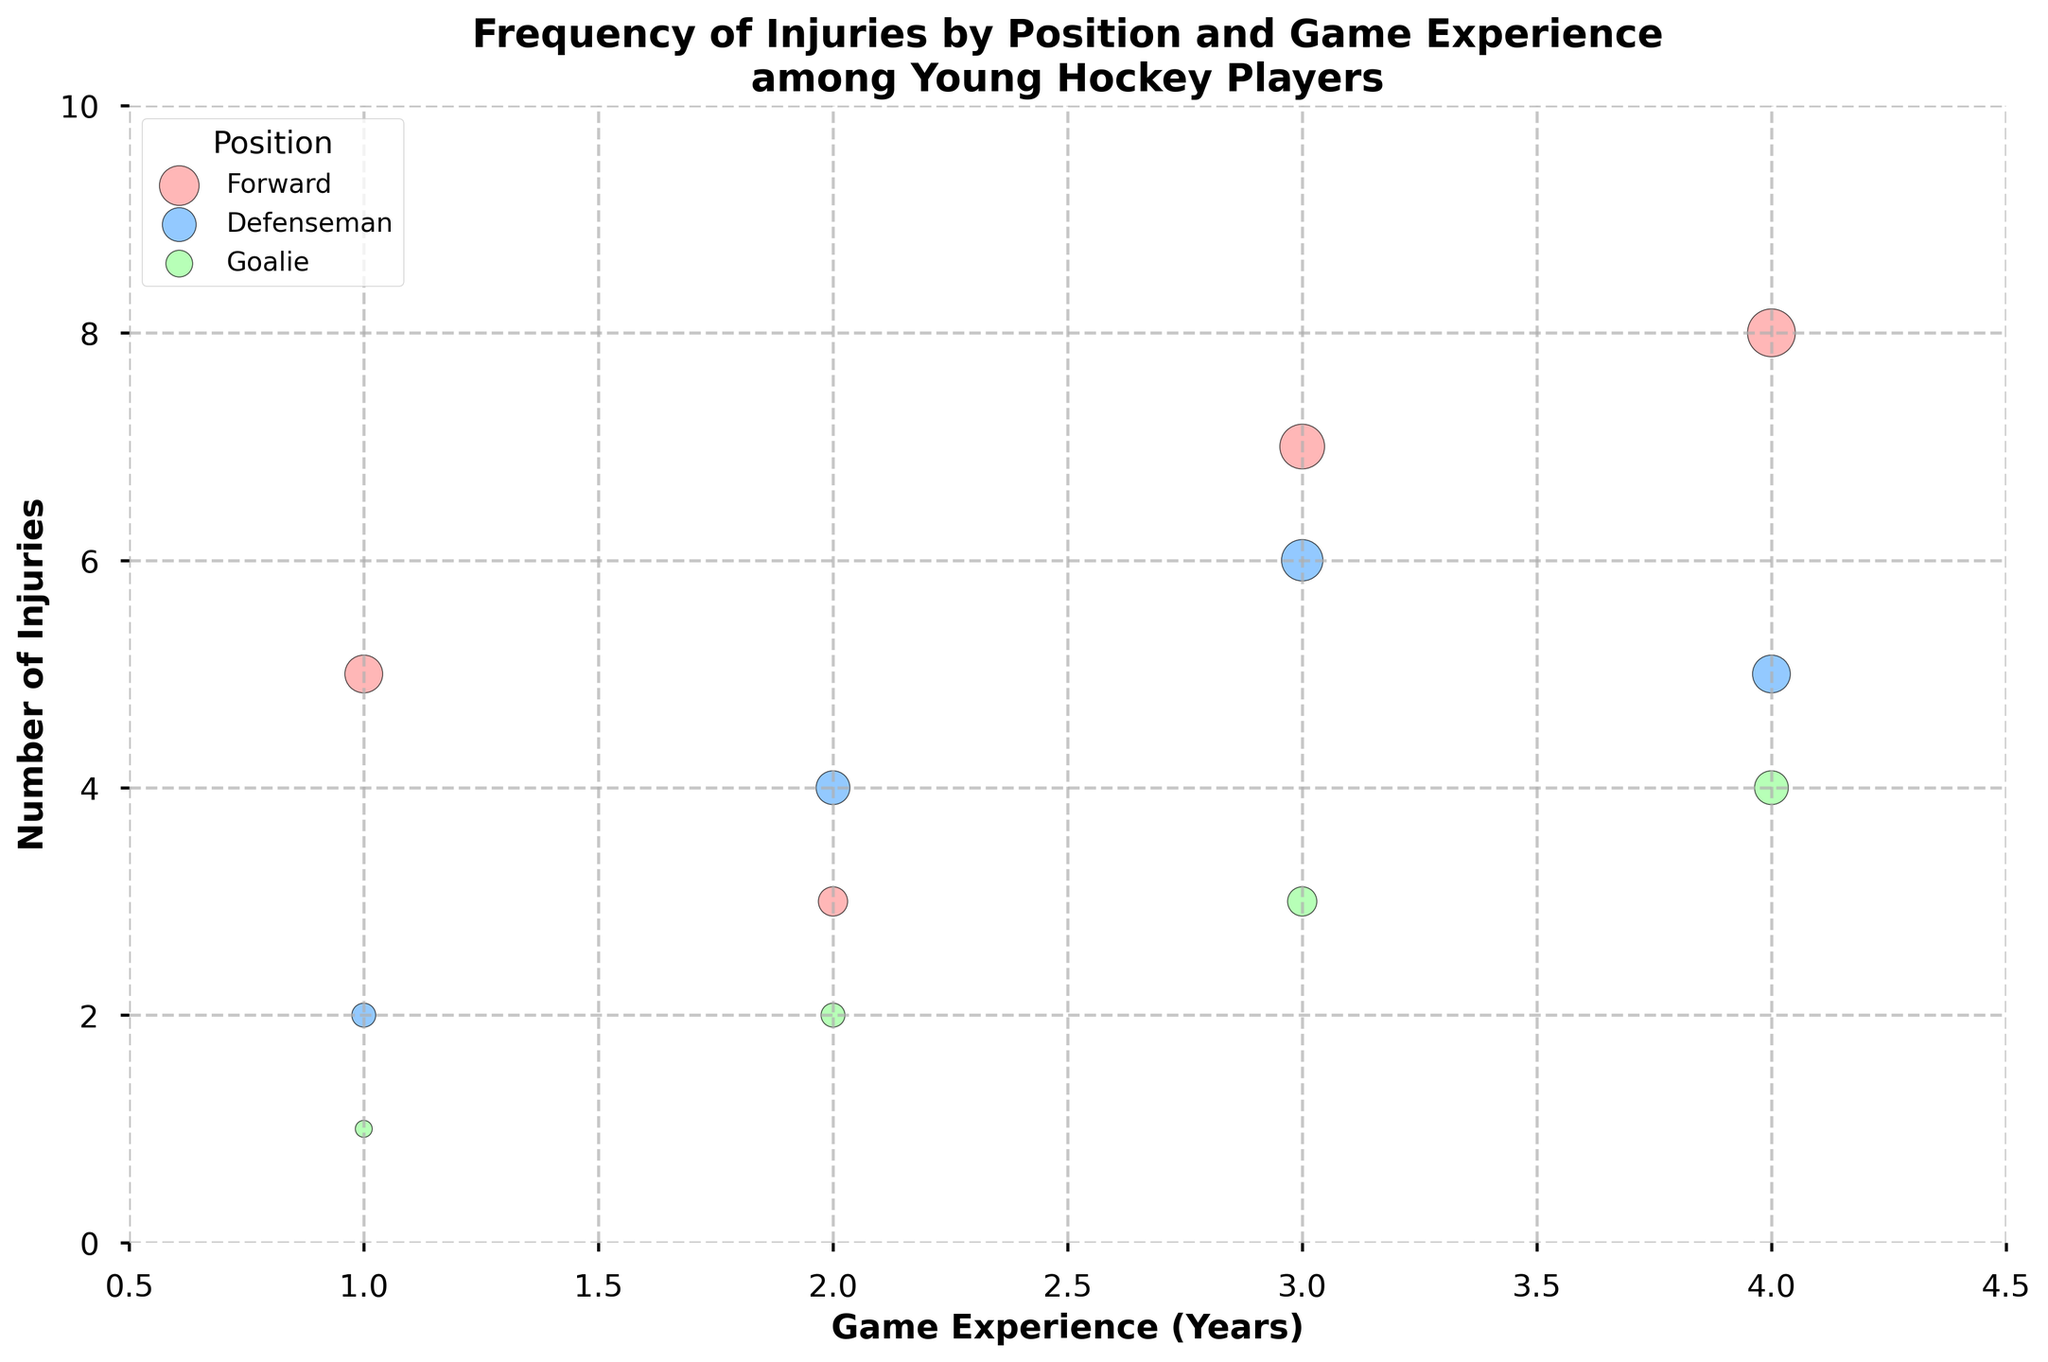What's the title of the figure? The title is located at the top of the figure and summarizes the main focus of the plot.
Answer: Frequency of Injuries by Position and Game Experience among Young Hockey Players What's the y-axis label? The y-axis label is situated along the vertical axis and indicates what is being measured on that axis.
Answer: Number of Injuries How many years of game experience are shown on the x-axis? The x-axis contains tick marks representing the values for game experience, ranging from the lowest to the highest value. Count these tick marks.
Answer: 4 years Which position has the most injuries overall? Count the total number of injuries for each position and compare to see which has the highest total. Forward: 5+3+7+8 = 23, Defenseman: 2+4+6+5 = 17, Goalie: 1+2+3+4 = 10.
Answer: Forward Which game experience year had the highest number of injuries among all positions combined? For each year of game experience, add the number of injuries across all positions and compare the sums. Year 1: 5+2+1 = 8, Year 2: 3+4+2 = 9, Year 3: 7+6+3 = 16, Year 4: 8+5+4 = 17.
Answer: 4 years Between forwards and defensemen, which position has more injuries after 2 years of experience? Look at the data points for 2 years of game experience for both positions. For defensemen: 4, for forwards: 3. Compare these numbers.
Answer: Defensemen How do the number of injuries for goalies change with game experience? Examine the data points for goalies over different years of experience (1, 2, 3, and 4 years) and observe the trend. 1 year: 1, 2 years: 2, 3 years: 3, 4 years: 4.
Answer: Increases How does the size of the bubble relate to the number of injuries? The size of each bubble represents the number of injuries, with larger bubbles indicating more injuries. This is evident from the plot legend and visual representation.
Answer: Bigger bubble, more injuries What trend do you observe in the number of injuries for defensemen as they gain more game experience? Look at the trend for defensemen from 1 to 4 years of experience. Data points: 1 year: 2, 2 years: 4, 3 years: 6, 4 years: 5.
Answer: Increases then slightly decreases Are there any positions with the same number of injuries at any point in terms of game experience? Compare the number of injuries across different positions for each year of game experience to find any matches. Defenseman and Goalie both have 2 injuries with 2 years of experience.
Answer: Yes, Defenseman and Goalie with 2 injuries at 2 years 